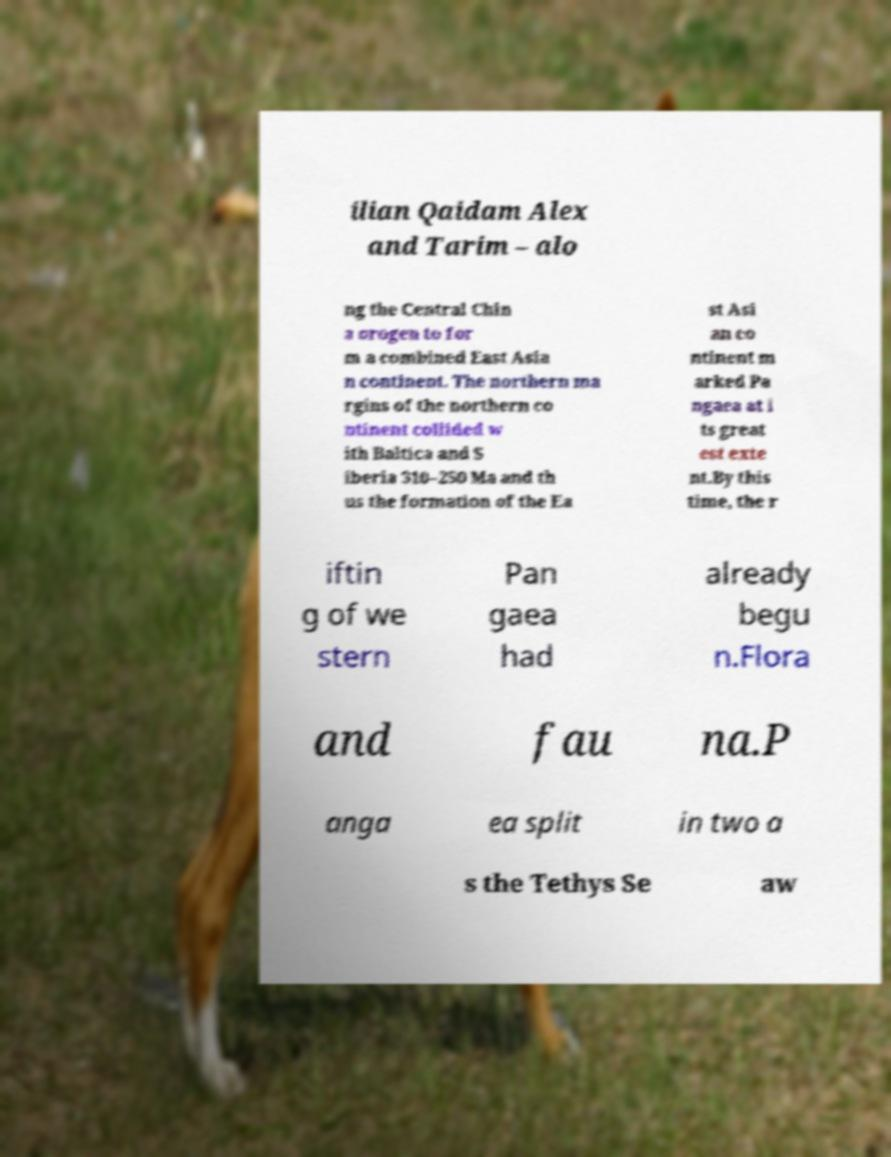Can you accurately transcribe the text from the provided image for me? ilian Qaidam Alex and Tarim – alo ng the Central Chin a orogen to for m a combined East Asia n continent. The northern ma rgins of the northern co ntinent collided w ith Baltica and S iberia 310–250 Ma and th us the formation of the Ea st Asi an co ntinent m arked Pa ngaea at i ts great est exte nt.By this time, the r iftin g of we stern Pan gaea had already begu n.Flora and fau na.P anga ea split in two a s the Tethys Se aw 